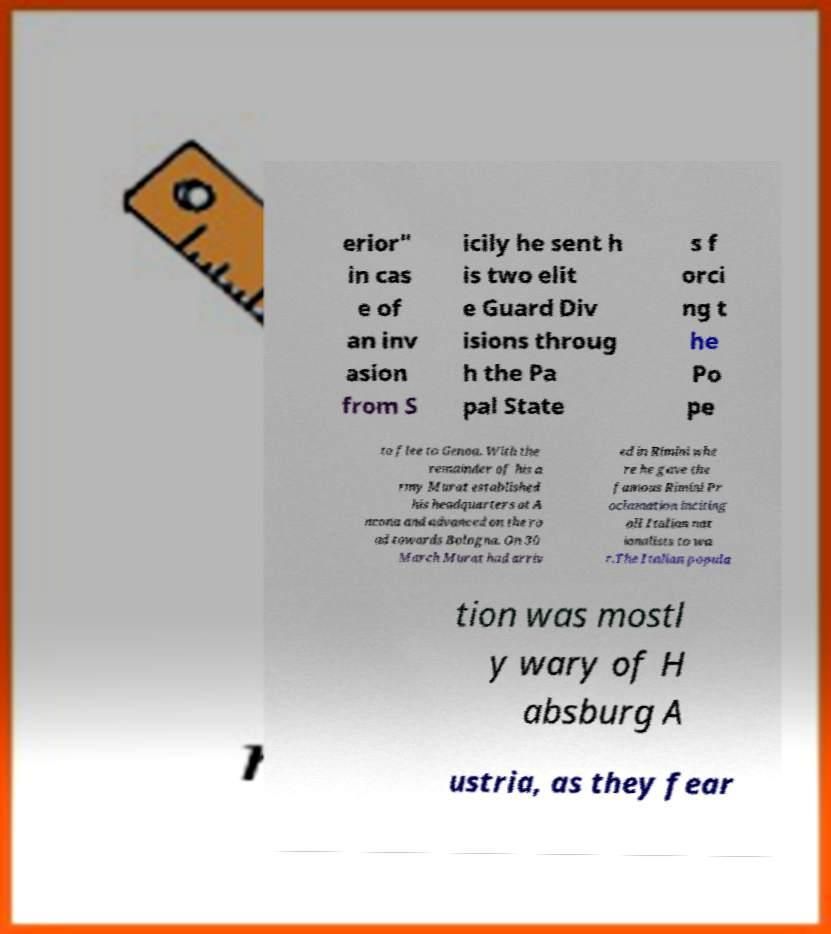Could you assist in decoding the text presented in this image and type it out clearly? erior" in cas e of an inv asion from S icily he sent h is two elit e Guard Div isions throug h the Pa pal State s f orci ng t he Po pe to flee to Genoa. With the remainder of his a rmy Murat established his headquarters at A ncona and advanced on the ro ad towards Bologna. On 30 March Murat had arriv ed in Rimini whe re he gave the famous Rimini Pr oclamation inciting all Italian nat ionalists to wa r.The Italian popula tion was mostl y wary of H absburg A ustria, as they fear 